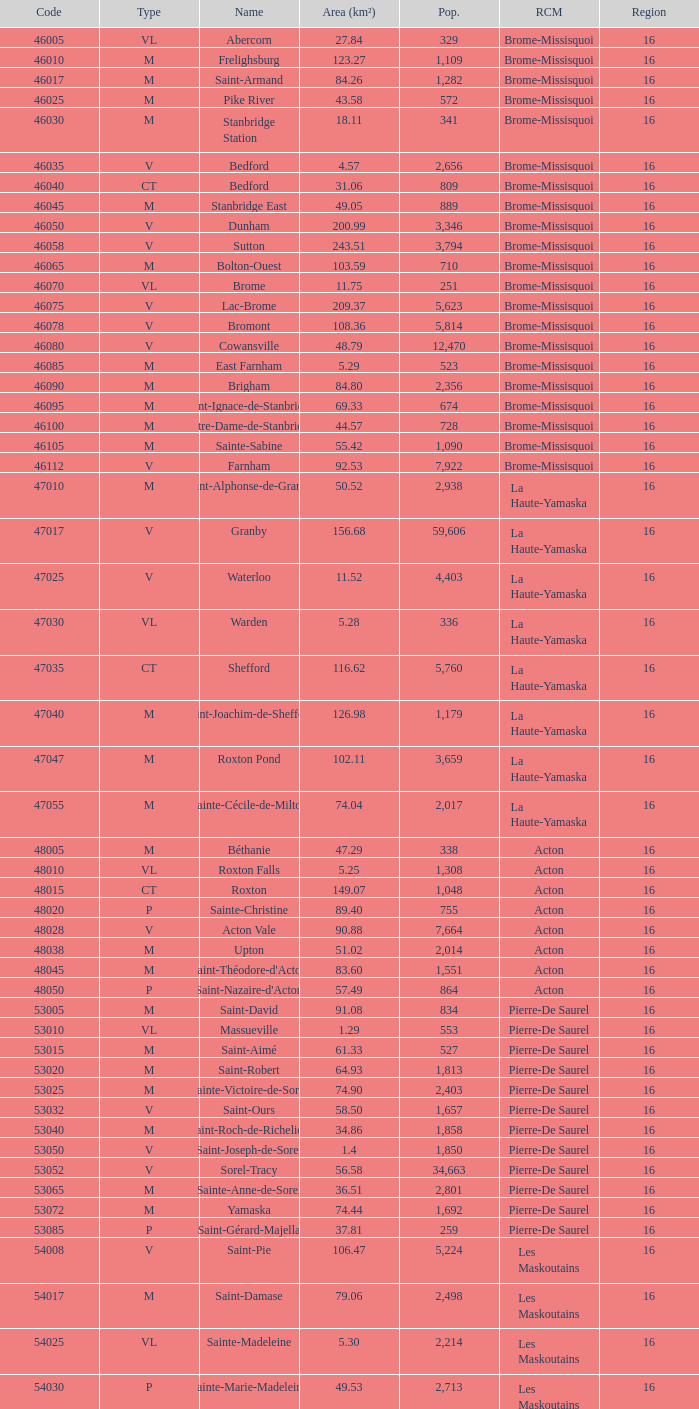Cowansville has less than 16 regions and is a Brome-Missisquoi Municipality, what is their population? None. 